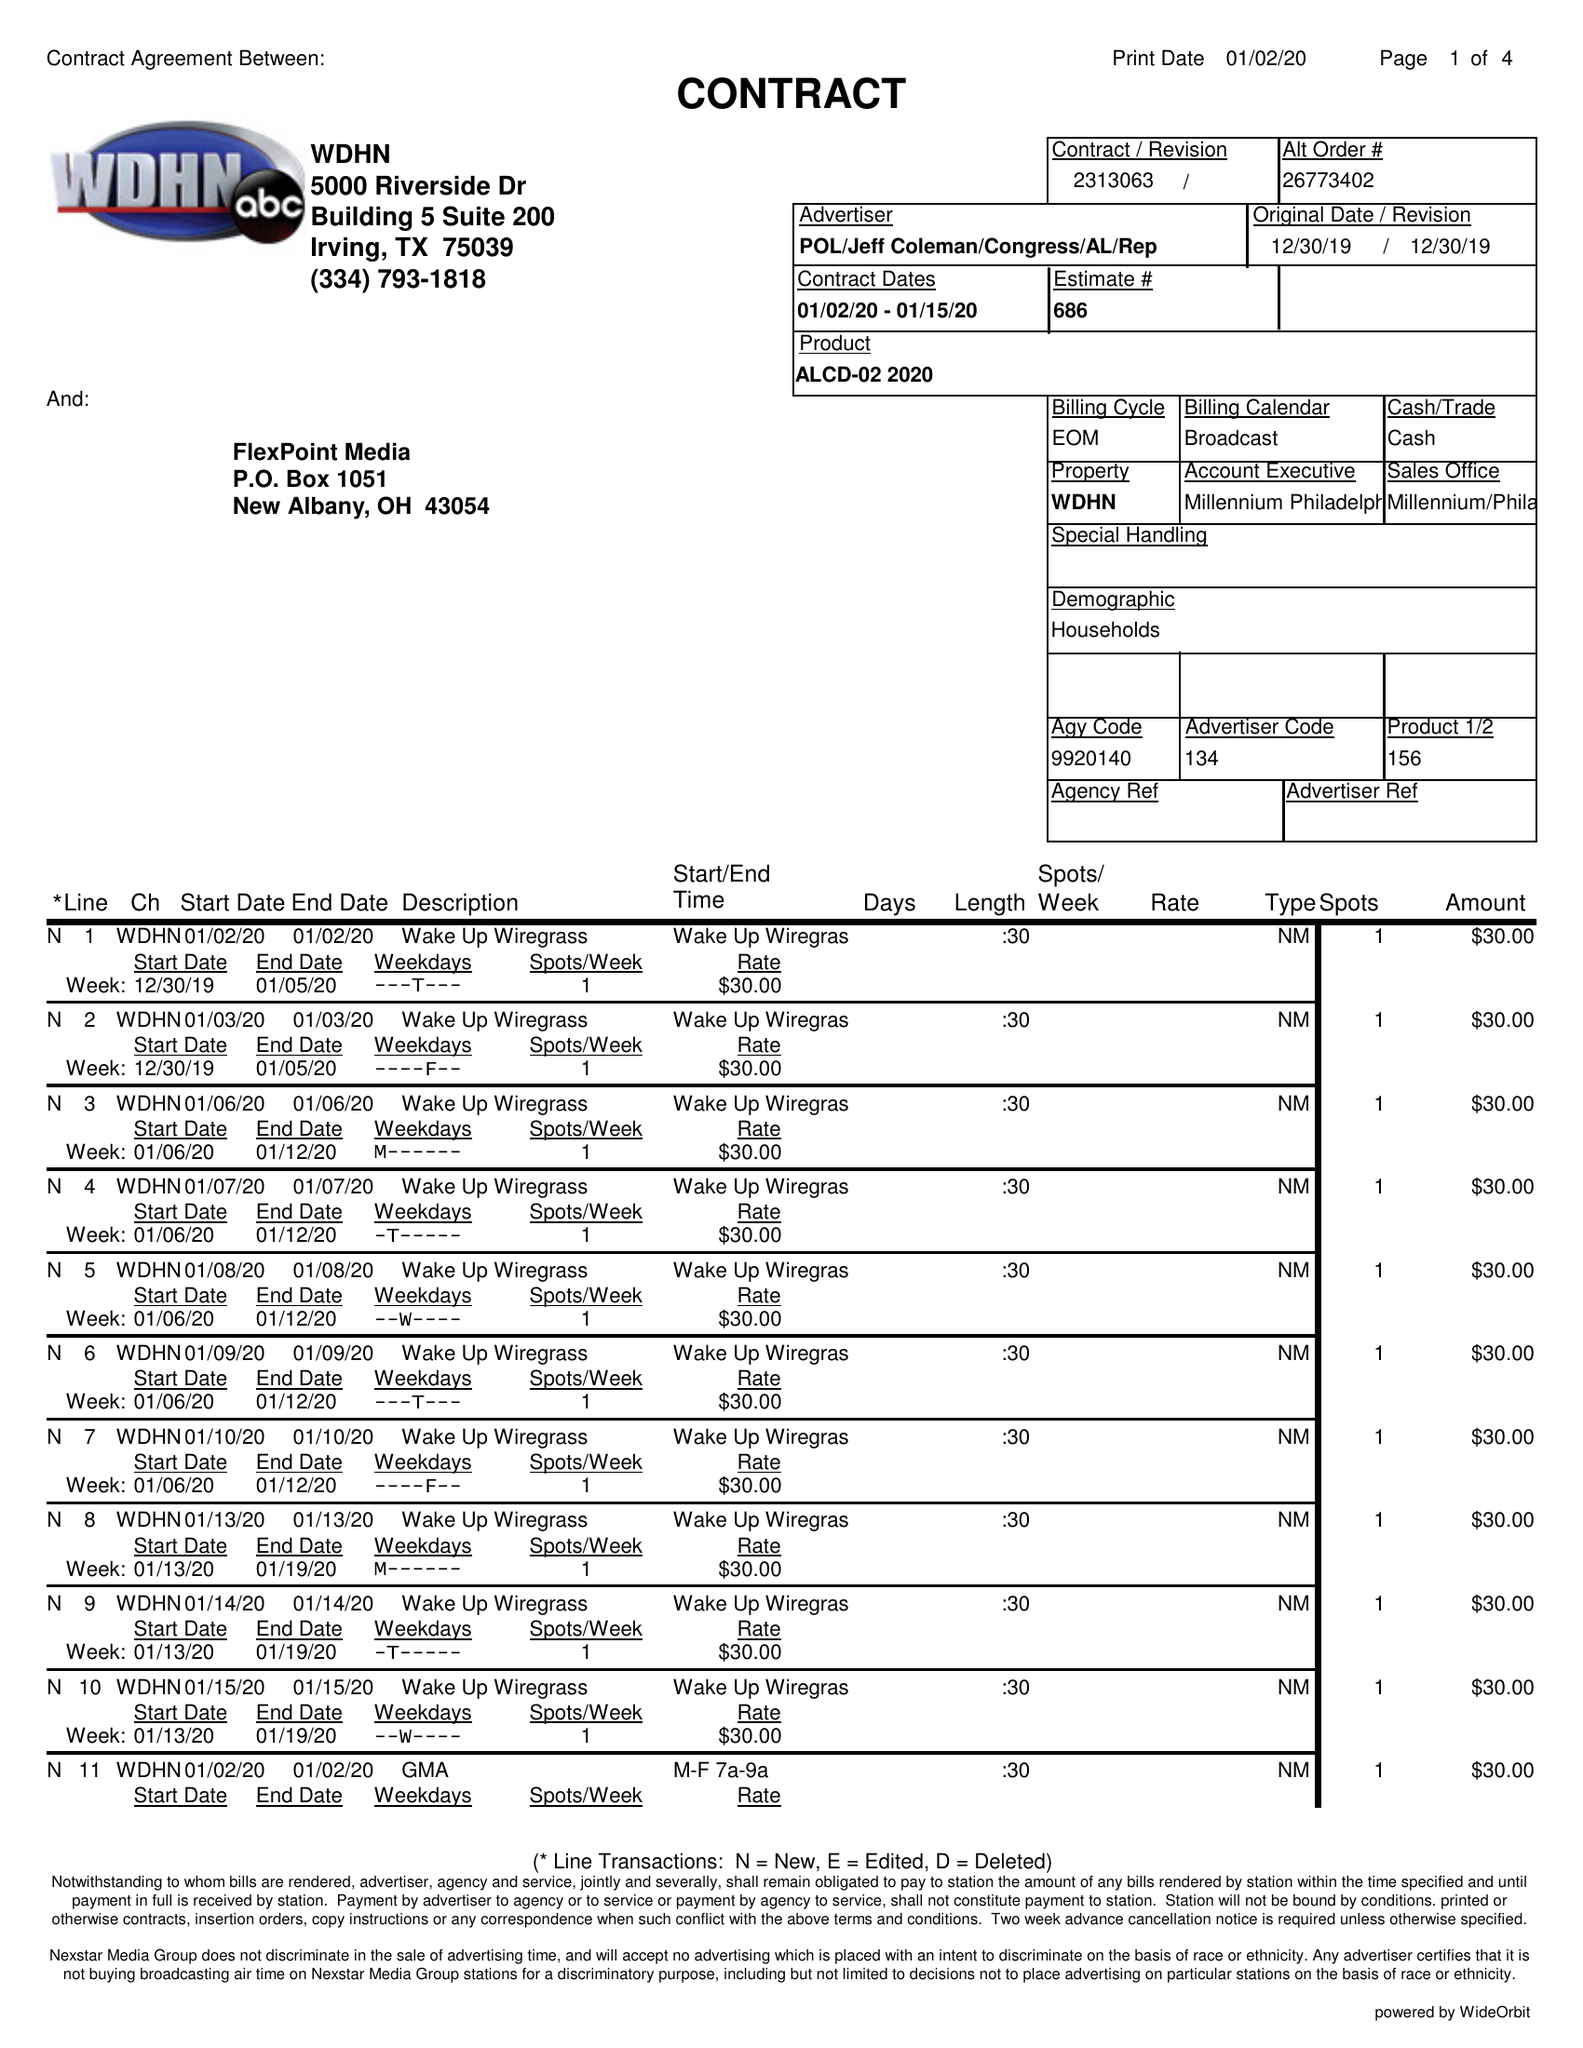What is the value for the advertiser?
Answer the question using a single word or phrase. POL/JEFFCOLEMAN/CONGRESS/AL/REP 